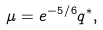<formula> <loc_0><loc_0><loc_500><loc_500>\mu = e ^ { - 5 / 6 } q ^ { * } ,</formula> 